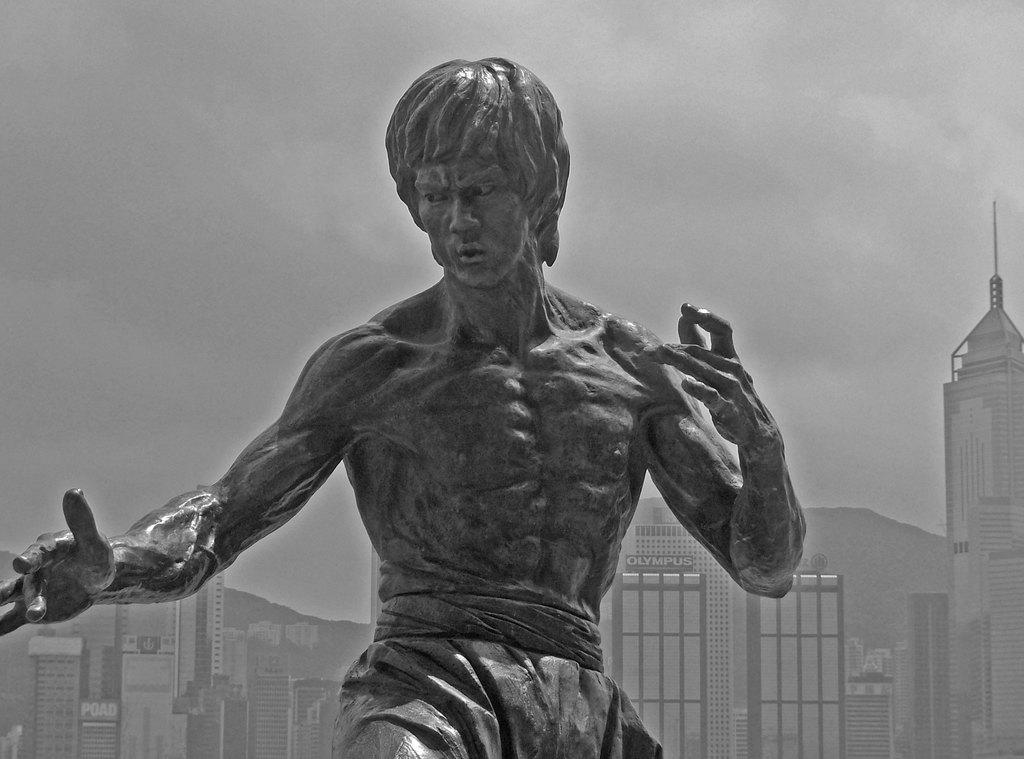What is the main subject in the center of the image? There is a statue in the center of the image. What can be seen in the background of the image? There are buildings and the sky visible in the background of the image. What type of amusement can be seen on the stranger's brain in the image? There is no stranger or brain present in the image; it features a statue and buildings in the background. 